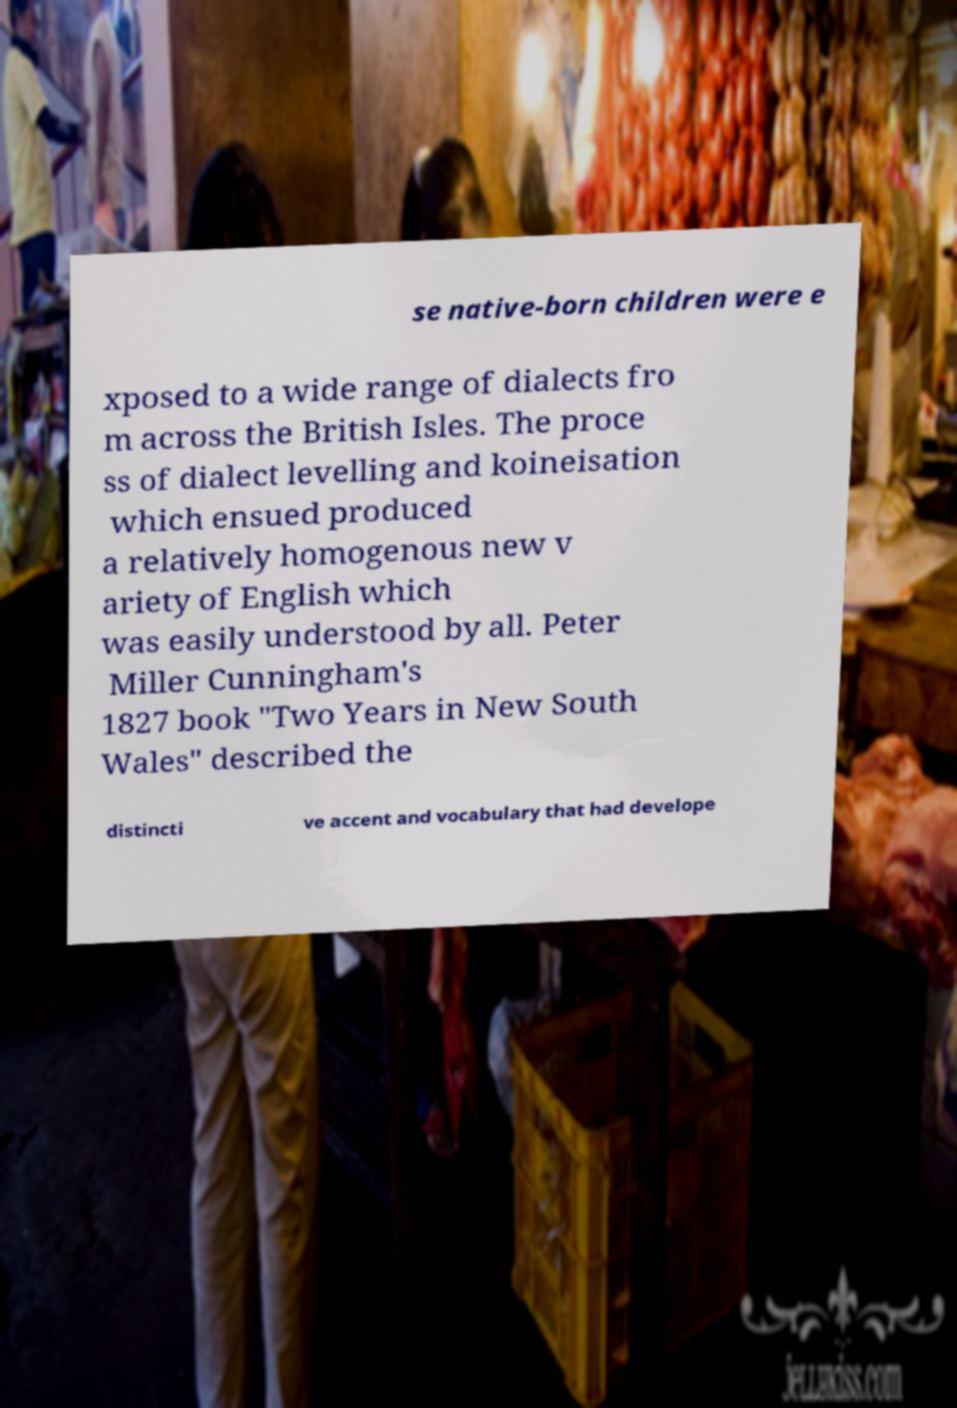There's text embedded in this image that I need extracted. Can you transcribe it verbatim? se native-born children were e xposed to a wide range of dialects fro m across the British Isles. The proce ss of dialect levelling and koineisation which ensued produced a relatively homogenous new v ariety of English which was easily understood by all. Peter Miller Cunningham's 1827 book "Two Years in New South Wales" described the distincti ve accent and vocabulary that had develope 